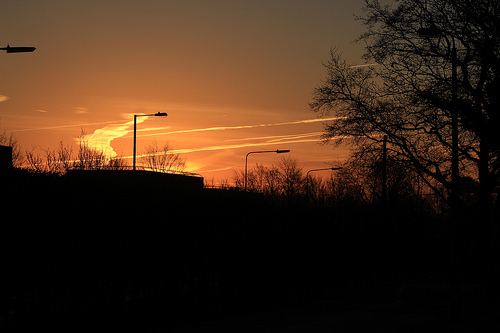<image>
Is the sky on the tree? No. The sky is not positioned on the tree. They may be near each other, but the sky is not supported by or resting on top of the tree. 